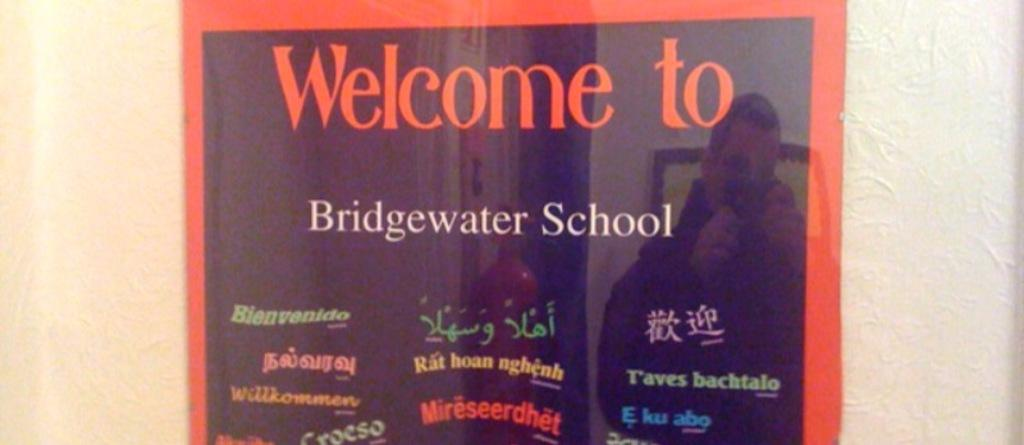What type of board is in the image? There is a glass board in the image. How is the glass board positioned in the image? The glass board is attached to the wall. What can be seen written on the glass board? There are words written on the glass board. What else can be seen on the glass board? There is a reflection of a person and reflections of other objects on the glass board. How does the glass board help the person drive their car in the image? The image does not show a car or any driving activity, so the glass board is not related to driving in this context. 